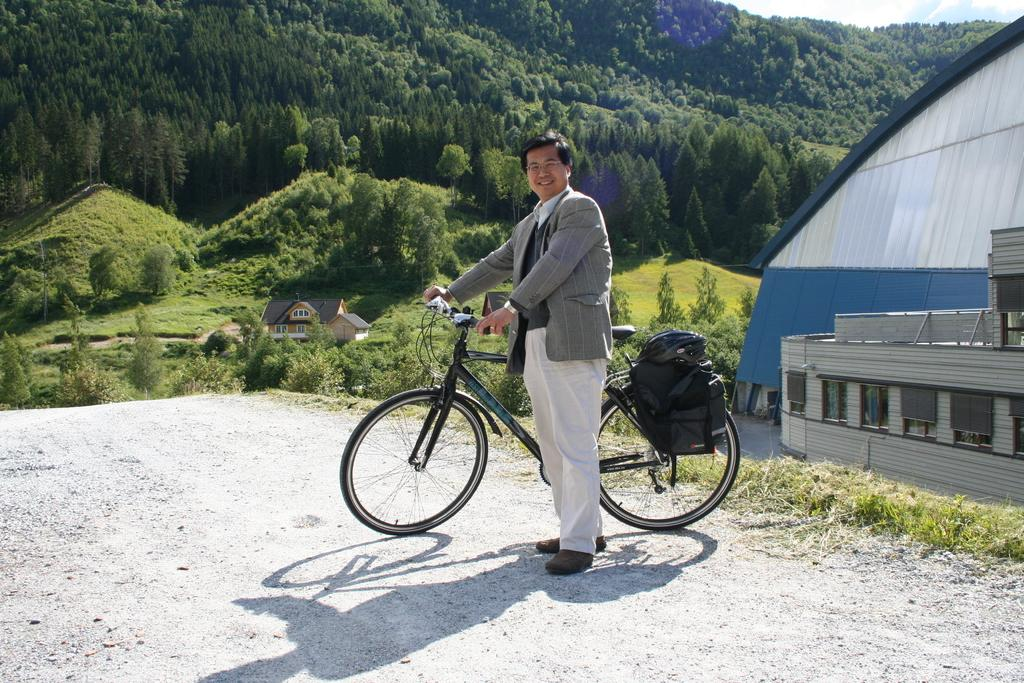What is the main subject of the image? There is a man in the image. What is the man doing in the image? The man is standing on the ground and holding a bicycle. What can be seen in the background of the image? There are trees, shrubs, bushes, buildings, and the sky visible in the background of the image. What type of sheet is covering the bicycle in the image? There is no sheet covering the bicycle in the image; the man is holding it. How many wings can be seen on the man in the image? The man does not have any wings in the image; he is a human. 